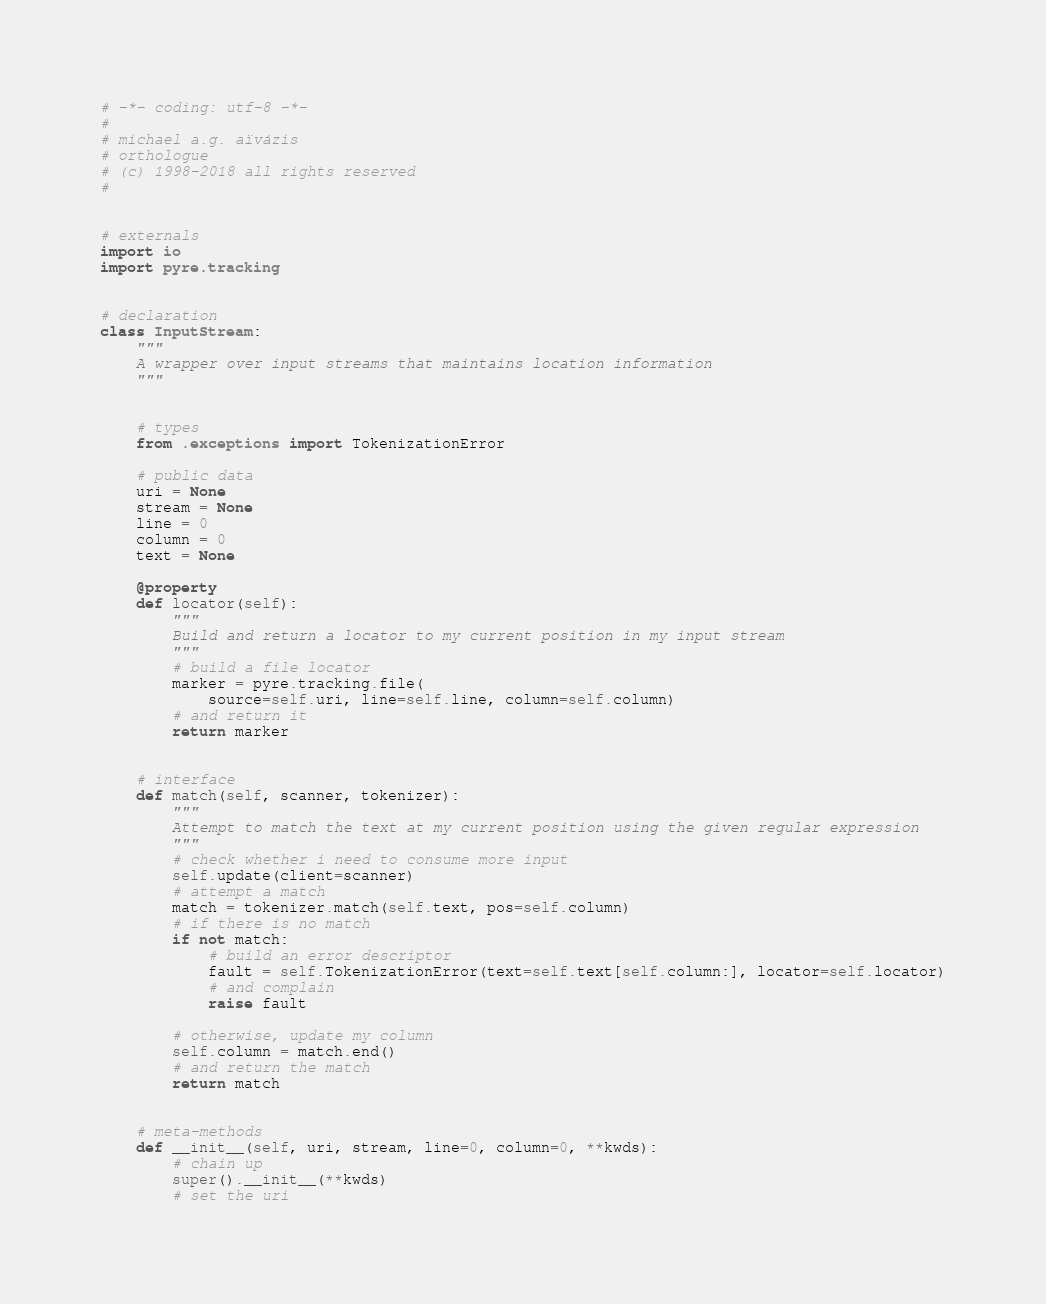Convert code to text. <code><loc_0><loc_0><loc_500><loc_500><_Python_># -*- coding: utf-8 -*-
#
# michael a.g. aïvázis
# orthologue
# (c) 1998-2018 all rights reserved
#


# externals
import io
import pyre.tracking


# declaration
class InputStream:
    """
    A wrapper over input streams that maintains location information
    """


    # types
    from .exceptions import TokenizationError

    # public data
    uri = None
    stream = None
    line = 0
    column = 0
    text = None

    @property
    def locator(self):
        """
        Build and return a locator to my current position in my input stream
        """
        # build a file locator
        marker = pyre.tracking.file(
            source=self.uri, line=self.line, column=self.column)
        # and return it
        return marker


    # interface
    def match(self, scanner, tokenizer):
        """
        Attempt to match the text at my current position using the given regular expression
        """
        # check whether i need to consume more input
        self.update(client=scanner)
        # attempt a match
        match = tokenizer.match(self.text, pos=self.column)
        # if there is no match
        if not match:
            # build an error descriptor
            fault = self.TokenizationError(text=self.text[self.column:], locator=self.locator)
            # and complain
            raise fault

        # otherwise, update my column
        self.column = match.end()
        # and return the match
        return match


    # meta-methods
    def __init__(self, uri, stream, line=0, column=0, **kwds):
        # chain up
        super().__init__(**kwds)
        # set the uri</code> 